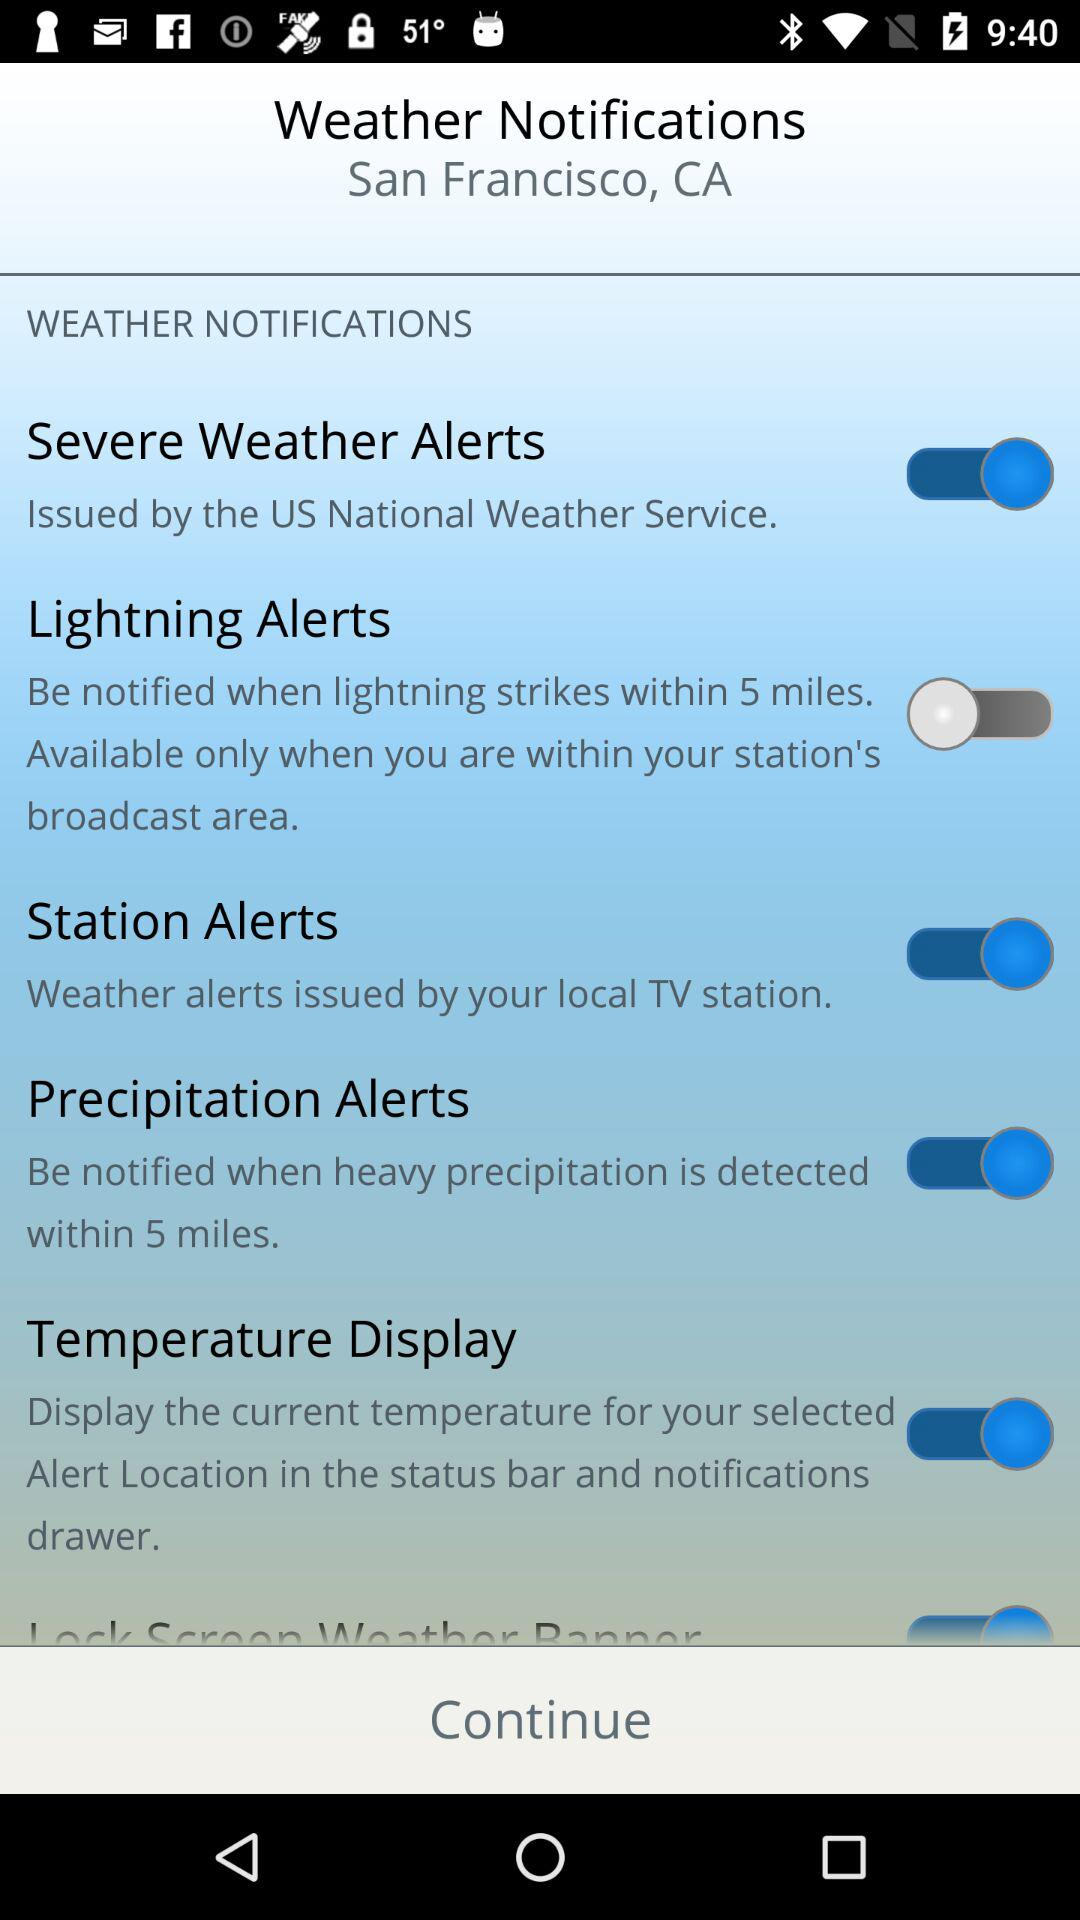What is the location? The location is San Francisco, CA. 